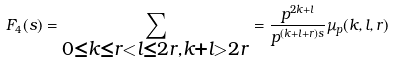Convert formula to latex. <formula><loc_0><loc_0><loc_500><loc_500>F _ { 4 } ( s ) = \sum _ { \substack { 0 \leq k \leq r < l \leq 2 r , k + l > 2 r } } = \frac { p ^ { 2 k + l } } { p ^ { ( k + l + r ) s } } \mu _ { p } ( k , l , r )</formula> 